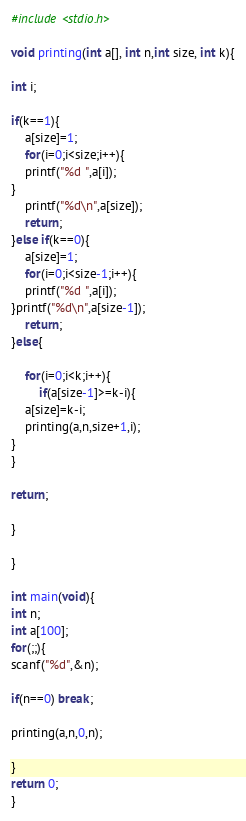<code> <loc_0><loc_0><loc_500><loc_500><_C_>#include <stdio.h>

void printing(int a[], int n,int size, int k){

int i;

if(k==1){
	a[size]=1;
	for(i=0;i<size;i++){
	printf("%d ",a[i]);
}
	printf("%d\n",a[size]);
	return;
}else if(k==0){
	a[size]=1;
	for(i=0;i<size-1;i++){
	printf("%d ",a[i]);
}printf("%d\n",a[size-1]);
	return;
}else{

	for(i=0;i<k;i++){
		if(a[size-1]>=k-i){
	a[size]=k-i;
	printing(a,n,size+1,i);
}
}

return;

}

}

int main(void){
int n;
int a[100];
for(;;){
scanf("%d",&n);

if(n==0) break;

printing(a,n,0,n);

}
return 0;
}</code> 